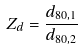Convert formula to latex. <formula><loc_0><loc_0><loc_500><loc_500>Z _ { d } = \frac { d _ { 8 0 , 1 } } { d _ { 8 0 , 2 } }</formula> 